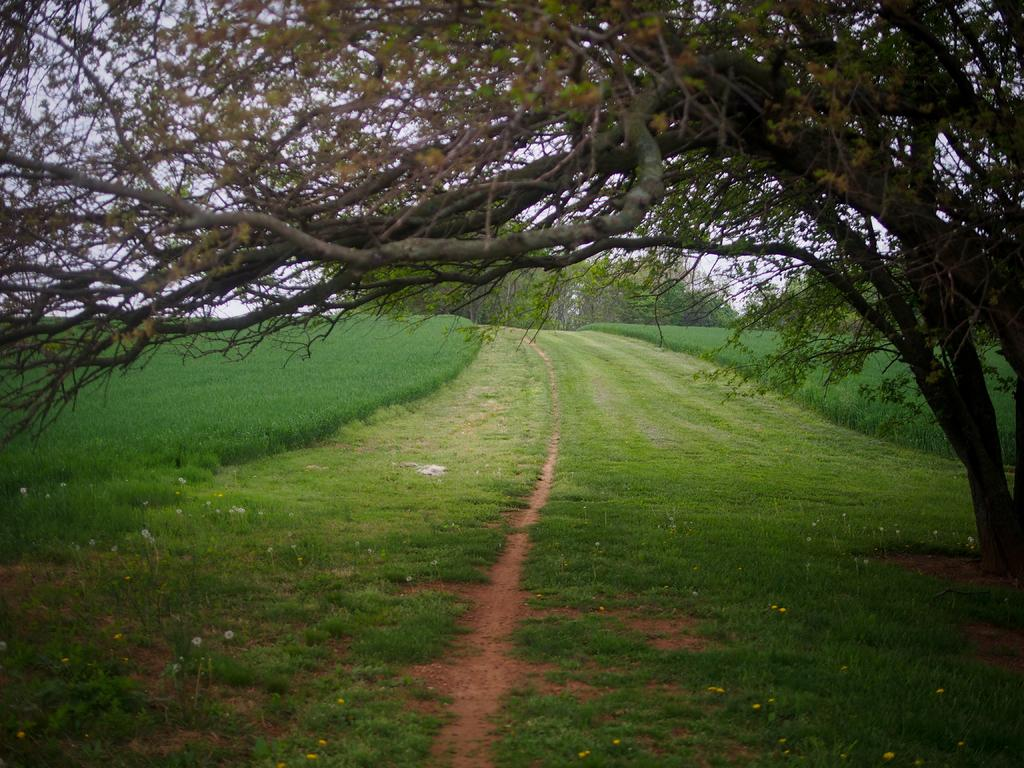What type of vegetation can be seen in the image? There is grass in the image. What other natural elements are present in the image? There are trees in the image. What can be seen in the background of the image? The sky is visible in the background of the image. Where is the oven located in the image? There is no oven present in the image. What type of light source is illuminating the grass in the image? The image does not provide information about the light source; it only shows the grass, trees, and sky. 